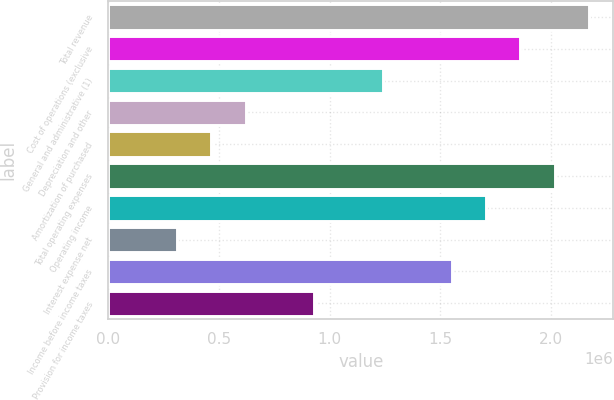Convert chart to OTSL. <chart><loc_0><loc_0><loc_500><loc_500><bar_chart><fcel>Total revenue<fcel>Cost of operations (exclusive<fcel>General and administrative (1)<fcel>Depreciation and other<fcel>Amortization of purchased<fcel>Total operating expenses<fcel>Operating income<fcel>Interest expense net<fcel>Income before income taxes<fcel>Provision for income taxes<nl><fcel>2.17341e+06<fcel>1.86292e+06<fcel>1.24195e+06<fcel>620976<fcel>465732<fcel>2.01817e+06<fcel>1.70768e+06<fcel>310489<fcel>1.55244e+06<fcel>931463<nl></chart> 